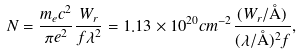<formula> <loc_0><loc_0><loc_500><loc_500>N = \frac { m _ { e } c ^ { 2 } } { \pi e ^ { 2 } } \frac { W _ { r } } { f \lambda ^ { 2 } } = 1 . 1 3 \times 1 0 ^ { 2 0 } c m ^ { - 2 } \frac { ( W _ { r } / \AA ) } { ( \lambda / \AA ) ^ { 2 } f } ,</formula> 